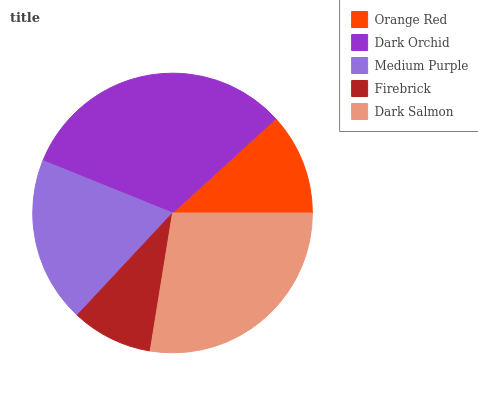Is Firebrick the minimum?
Answer yes or no. Yes. Is Dark Orchid the maximum?
Answer yes or no. Yes. Is Medium Purple the minimum?
Answer yes or no. No. Is Medium Purple the maximum?
Answer yes or no. No. Is Dark Orchid greater than Medium Purple?
Answer yes or no. Yes. Is Medium Purple less than Dark Orchid?
Answer yes or no. Yes. Is Medium Purple greater than Dark Orchid?
Answer yes or no. No. Is Dark Orchid less than Medium Purple?
Answer yes or no. No. Is Medium Purple the high median?
Answer yes or no. Yes. Is Medium Purple the low median?
Answer yes or no. Yes. Is Dark Orchid the high median?
Answer yes or no. No. Is Dark Salmon the low median?
Answer yes or no. No. 